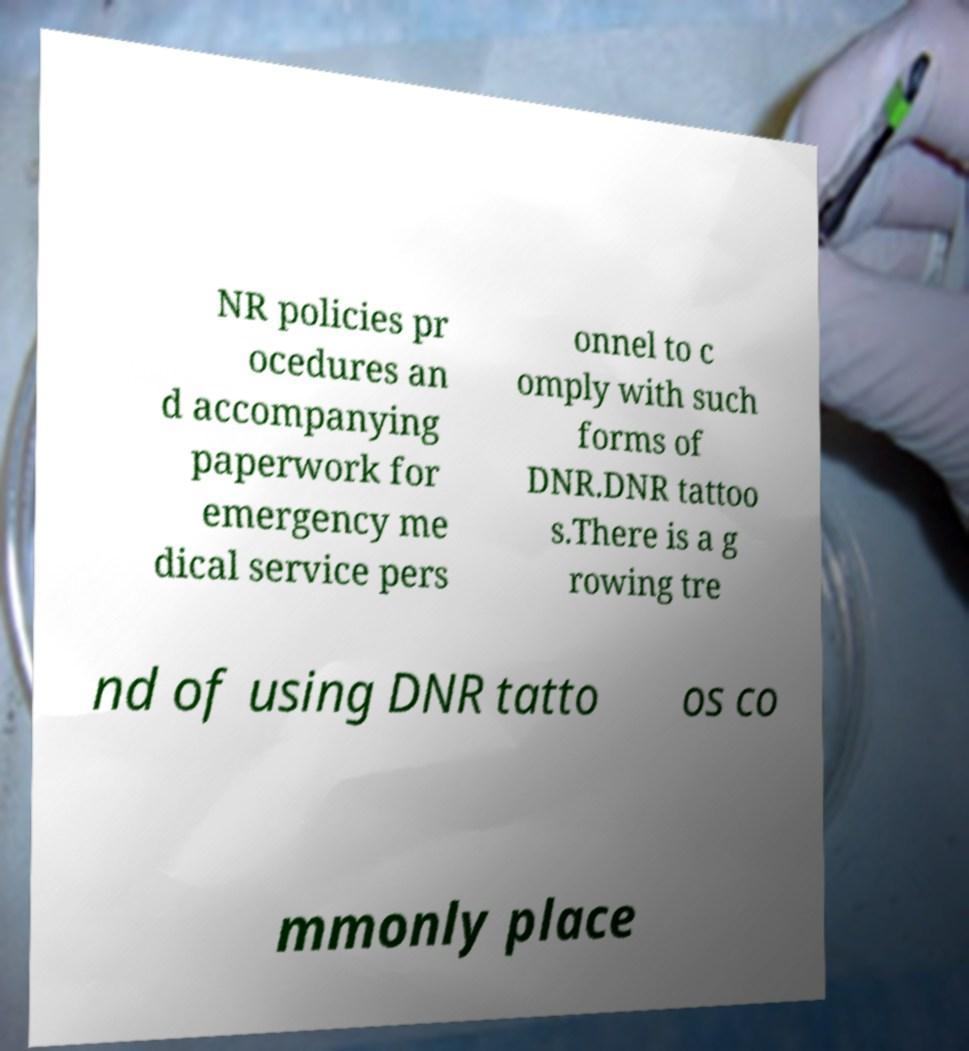Could you extract and type out the text from this image? NR policies pr ocedures an d accompanying paperwork for emergency me dical service pers onnel to c omply with such forms of DNR.DNR tattoo s.There is a g rowing tre nd of using DNR tatto os co mmonly place 